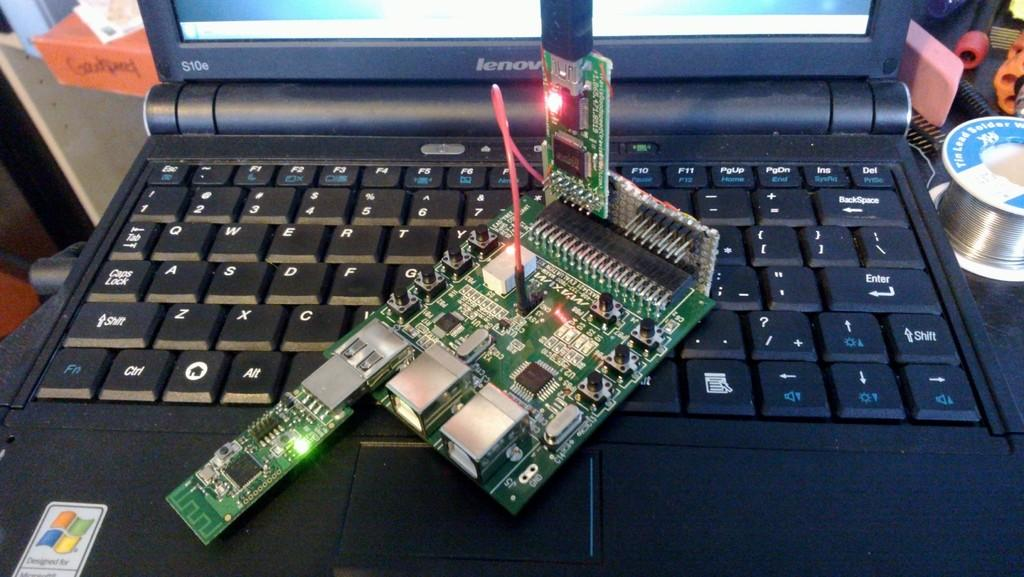<image>
Summarize the visual content of the image. A laptop, model S10e, has a circuit board sitting on top of the keyboard. 